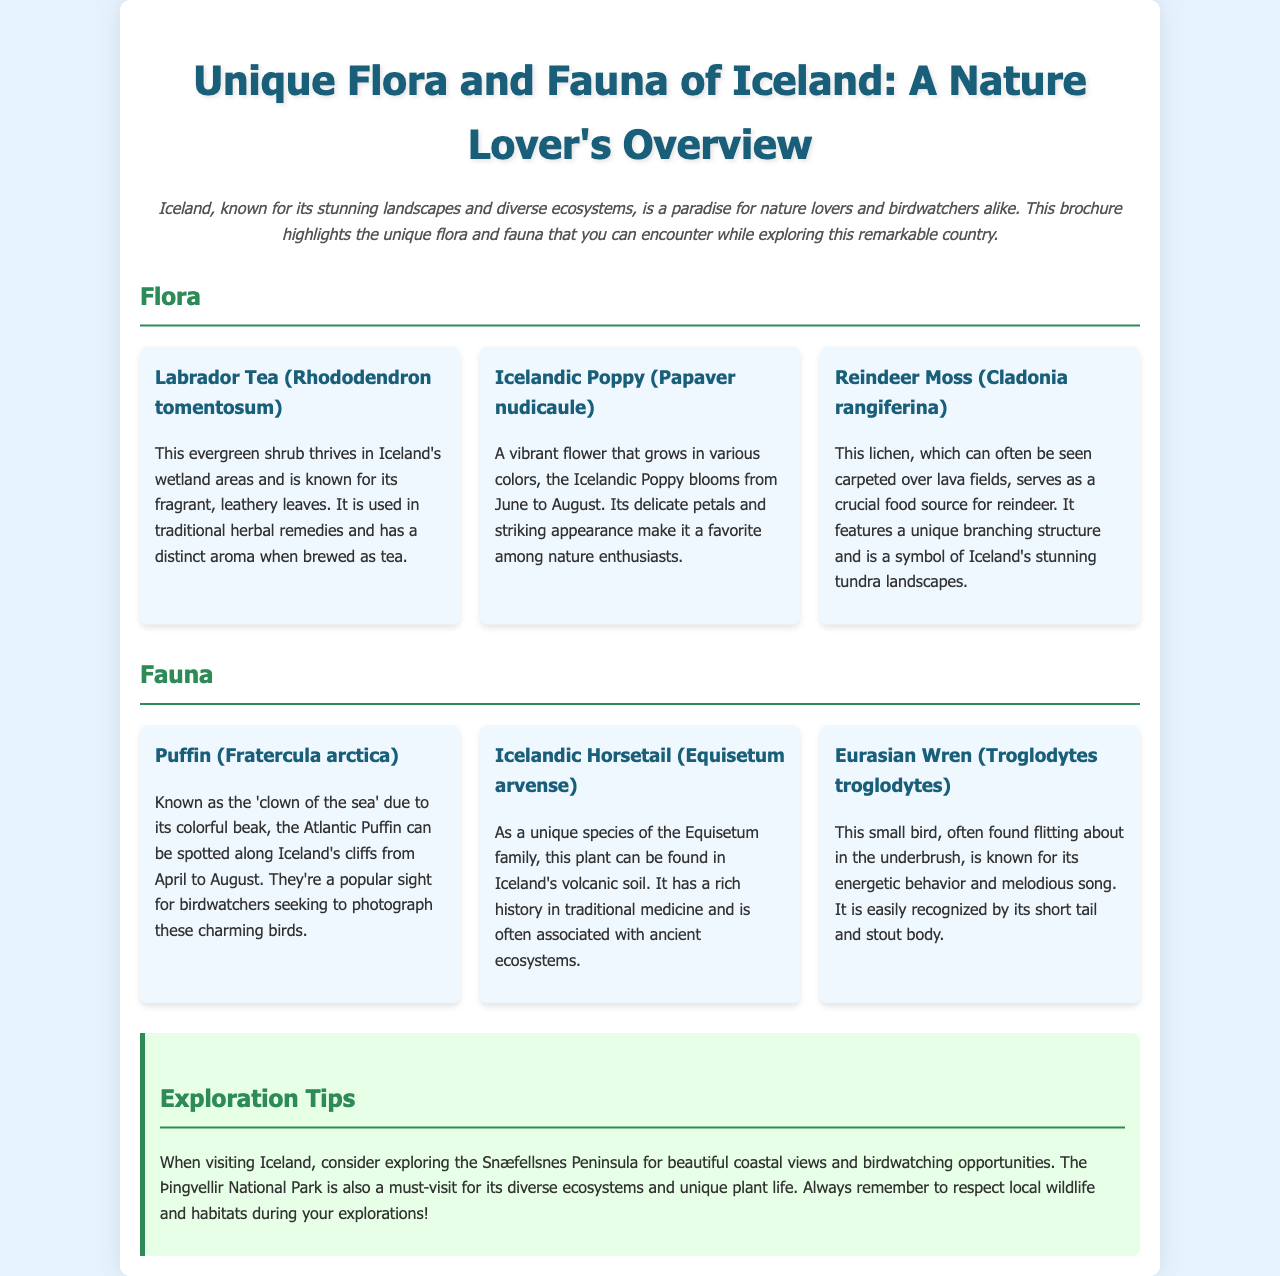What is the main theme of the brochure? The main theme is the unique flora and fauna found in Iceland.
Answer: unique flora and fauna of Iceland Which plant is known for its fragrant, leathery leaves? This information can be found under the Flora section, specifically mentioning Labrador Tea.
Answer: Labrador Tea During which months do Icelandic Poppies bloom? The document specifies that Icelandic Poppies bloom from June to August.
Answer: June to August What is referred to as the 'clown of the sea'? This phrase describes the Atlantic Puffin mentioned in the Fauna section.
Answer: Atlantic Puffin Which area is recommended for birdwatching opportunities? The exploration tips recommend the Snæfellsnes Peninsula for birdwatching.
Answer: Snæfellsnes Peninsula What type of ecosystem is the Þingvellir National Park known for? The park is noted for its diverse ecosystems in the exploration tips.
Answer: diverse ecosystems How does Reindeer Moss function in Iceland’s ecosystem? The document notes that it serves as a crucial food source for reindeer.
Answer: vital food source for reindeer Which structure provides a summary of specific flora and fauna? The Flora and Fauna grid summarizes the different species.
Answer: Flora and Fauna grid What is a distinctive feature of the Eurasian Wren? The document describes its short tail and stout body as distinctive features.
Answer: short tail and stout body 